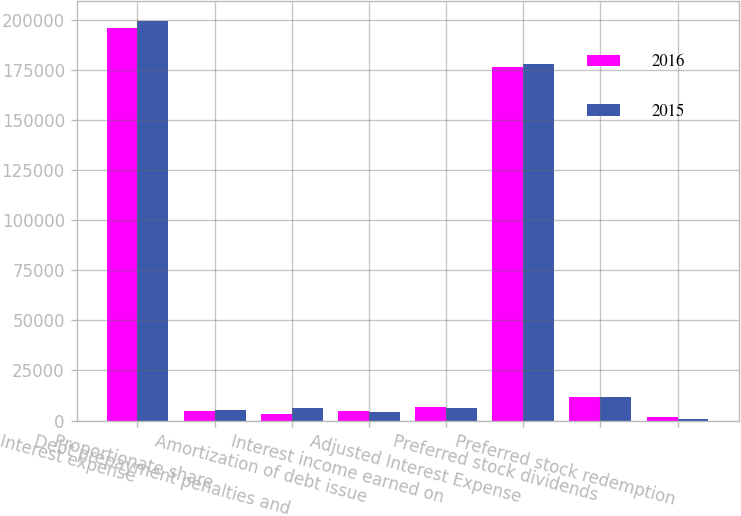<chart> <loc_0><loc_0><loc_500><loc_500><stacked_bar_chart><ecel><fcel>Interest expense<fcel>Proportionate share<fcel>Debt prepayment penalties and<fcel>Amortization of debt issue<fcel>Interest income earned on<fcel>Adjusted Interest Expense<fcel>Preferred stock dividends<fcel>Preferred stock redemption<nl><fcel>2016<fcel>196389<fcel>4841<fcel>3295<fcel>4685<fcel>6825<fcel>176743<fcel>11994<fcel>1980<nl><fcel>2015<fcel>199685<fcel>5262<fcel>6068<fcel>4227<fcel>6092<fcel>178036<fcel>11794<fcel>695<nl></chart> 